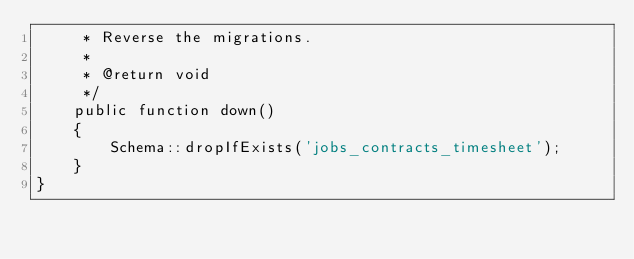Convert code to text. <code><loc_0><loc_0><loc_500><loc_500><_PHP_>     * Reverse the migrations.
     *
     * @return void
     */
    public function down()
    {
        Schema::dropIfExists('jobs_contracts_timesheet');
    }
}
</code> 